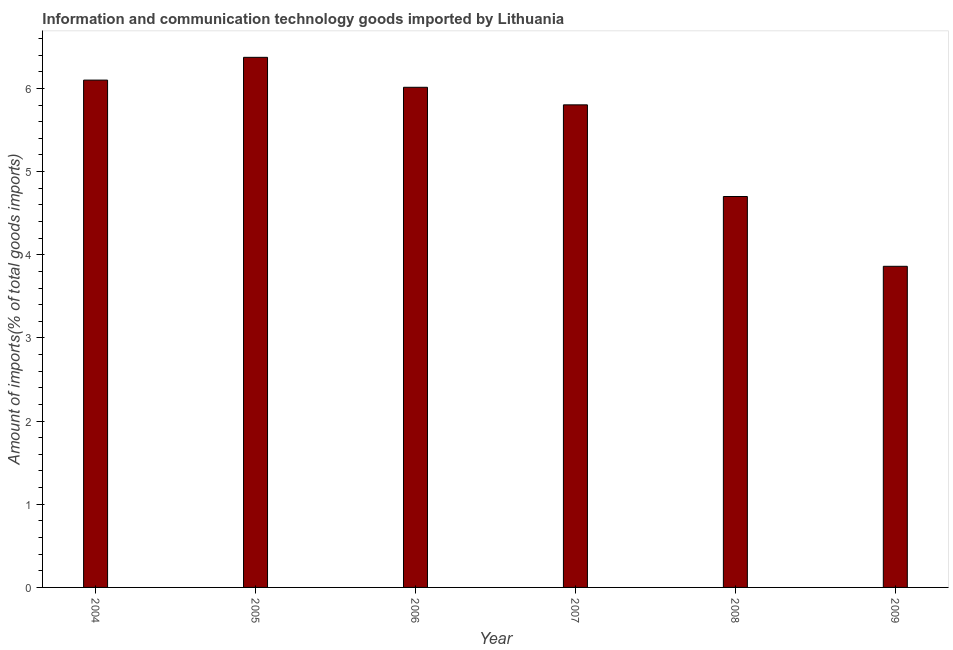Does the graph contain any zero values?
Your answer should be compact. No. Does the graph contain grids?
Your response must be concise. No. What is the title of the graph?
Your answer should be compact. Information and communication technology goods imported by Lithuania. What is the label or title of the X-axis?
Offer a terse response. Year. What is the label or title of the Y-axis?
Offer a terse response. Amount of imports(% of total goods imports). What is the amount of ict goods imports in 2008?
Offer a terse response. 4.7. Across all years, what is the maximum amount of ict goods imports?
Keep it short and to the point. 6.37. Across all years, what is the minimum amount of ict goods imports?
Ensure brevity in your answer.  3.86. In which year was the amount of ict goods imports maximum?
Your response must be concise. 2005. What is the sum of the amount of ict goods imports?
Offer a terse response. 32.85. What is the difference between the amount of ict goods imports in 2004 and 2007?
Offer a terse response. 0.3. What is the average amount of ict goods imports per year?
Your answer should be very brief. 5.47. What is the median amount of ict goods imports?
Offer a terse response. 5.91. In how many years, is the amount of ict goods imports greater than 2.6 %?
Provide a short and direct response. 6. Do a majority of the years between 2009 and 2007 (inclusive) have amount of ict goods imports greater than 4.2 %?
Give a very brief answer. Yes. What is the ratio of the amount of ict goods imports in 2006 to that in 2008?
Offer a terse response. 1.28. What is the difference between the highest and the second highest amount of ict goods imports?
Your answer should be compact. 0.27. Is the sum of the amount of ict goods imports in 2007 and 2008 greater than the maximum amount of ict goods imports across all years?
Your answer should be very brief. Yes. What is the difference between the highest and the lowest amount of ict goods imports?
Offer a terse response. 2.51. How many bars are there?
Your answer should be compact. 6. Are all the bars in the graph horizontal?
Keep it short and to the point. No. How many years are there in the graph?
Keep it short and to the point. 6. What is the difference between two consecutive major ticks on the Y-axis?
Your response must be concise. 1. What is the Amount of imports(% of total goods imports) of 2004?
Keep it short and to the point. 6.1. What is the Amount of imports(% of total goods imports) in 2005?
Give a very brief answer. 6.37. What is the Amount of imports(% of total goods imports) of 2006?
Provide a short and direct response. 6.01. What is the Amount of imports(% of total goods imports) of 2007?
Ensure brevity in your answer.  5.8. What is the Amount of imports(% of total goods imports) of 2008?
Offer a terse response. 4.7. What is the Amount of imports(% of total goods imports) of 2009?
Your answer should be very brief. 3.86. What is the difference between the Amount of imports(% of total goods imports) in 2004 and 2005?
Keep it short and to the point. -0.27. What is the difference between the Amount of imports(% of total goods imports) in 2004 and 2006?
Make the answer very short. 0.09. What is the difference between the Amount of imports(% of total goods imports) in 2004 and 2007?
Make the answer very short. 0.3. What is the difference between the Amount of imports(% of total goods imports) in 2004 and 2008?
Offer a terse response. 1.4. What is the difference between the Amount of imports(% of total goods imports) in 2004 and 2009?
Offer a terse response. 2.24. What is the difference between the Amount of imports(% of total goods imports) in 2005 and 2006?
Offer a very short reply. 0.36. What is the difference between the Amount of imports(% of total goods imports) in 2005 and 2007?
Offer a very short reply. 0.57. What is the difference between the Amount of imports(% of total goods imports) in 2005 and 2008?
Offer a terse response. 1.67. What is the difference between the Amount of imports(% of total goods imports) in 2005 and 2009?
Your answer should be very brief. 2.51. What is the difference between the Amount of imports(% of total goods imports) in 2006 and 2007?
Give a very brief answer. 0.21. What is the difference between the Amount of imports(% of total goods imports) in 2006 and 2008?
Your answer should be compact. 1.31. What is the difference between the Amount of imports(% of total goods imports) in 2006 and 2009?
Provide a short and direct response. 2.15. What is the difference between the Amount of imports(% of total goods imports) in 2007 and 2008?
Your answer should be compact. 1.1. What is the difference between the Amount of imports(% of total goods imports) in 2007 and 2009?
Ensure brevity in your answer.  1.94. What is the difference between the Amount of imports(% of total goods imports) in 2008 and 2009?
Provide a short and direct response. 0.84. What is the ratio of the Amount of imports(% of total goods imports) in 2004 to that in 2007?
Make the answer very short. 1.05. What is the ratio of the Amount of imports(% of total goods imports) in 2004 to that in 2008?
Ensure brevity in your answer.  1.3. What is the ratio of the Amount of imports(% of total goods imports) in 2004 to that in 2009?
Your response must be concise. 1.58. What is the ratio of the Amount of imports(% of total goods imports) in 2005 to that in 2006?
Give a very brief answer. 1.06. What is the ratio of the Amount of imports(% of total goods imports) in 2005 to that in 2007?
Give a very brief answer. 1.1. What is the ratio of the Amount of imports(% of total goods imports) in 2005 to that in 2008?
Provide a succinct answer. 1.36. What is the ratio of the Amount of imports(% of total goods imports) in 2005 to that in 2009?
Make the answer very short. 1.65. What is the ratio of the Amount of imports(% of total goods imports) in 2006 to that in 2007?
Your answer should be very brief. 1.04. What is the ratio of the Amount of imports(% of total goods imports) in 2006 to that in 2008?
Your response must be concise. 1.28. What is the ratio of the Amount of imports(% of total goods imports) in 2006 to that in 2009?
Provide a succinct answer. 1.56. What is the ratio of the Amount of imports(% of total goods imports) in 2007 to that in 2008?
Your response must be concise. 1.23. What is the ratio of the Amount of imports(% of total goods imports) in 2007 to that in 2009?
Ensure brevity in your answer.  1.5. What is the ratio of the Amount of imports(% of total goods imports) in 2008 to that in 2009?
Offer a terse response. 1.22. 